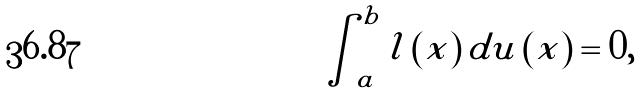<formula> <loc_0><loc_0><loc_500><loc_500>\int _ { a } ^ { b } l \left ( x \right ) d u \left ( x \right ) = 0 ,</formula> 